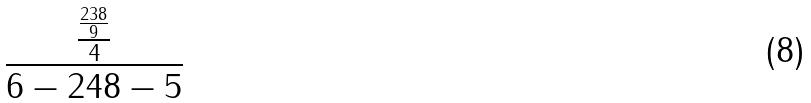Convert formula to latex. <formula><loc_0><loc_0><loc_500><loc_500>\frac { \frac { \frac { 2 3 8 } { 9 } } { 4 } } { 6 - 2 4 8 - 5 }</formula> 